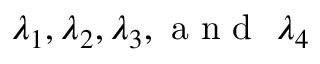<formula> <loc_0><loc_0><loc_500><loc_500>\lambda _ { 1 } , \lambda _ { 2 } , \lambda _ { 3 } , a n d \lambda _ { 4 }</formula> 